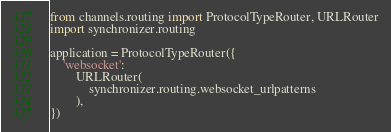Convert code to text. <code><loc_0><loc_0><loc_500><loc_500><_Python_>from channels.routing import ProtocolTypeRouter, URLRouter
import synchronizer.routing

application = ProtocolTypeRouter({
    'websocket':
        URLRouter(
            synchronizer.routing.websocket_urlpatterns
        ),
})
</code> 